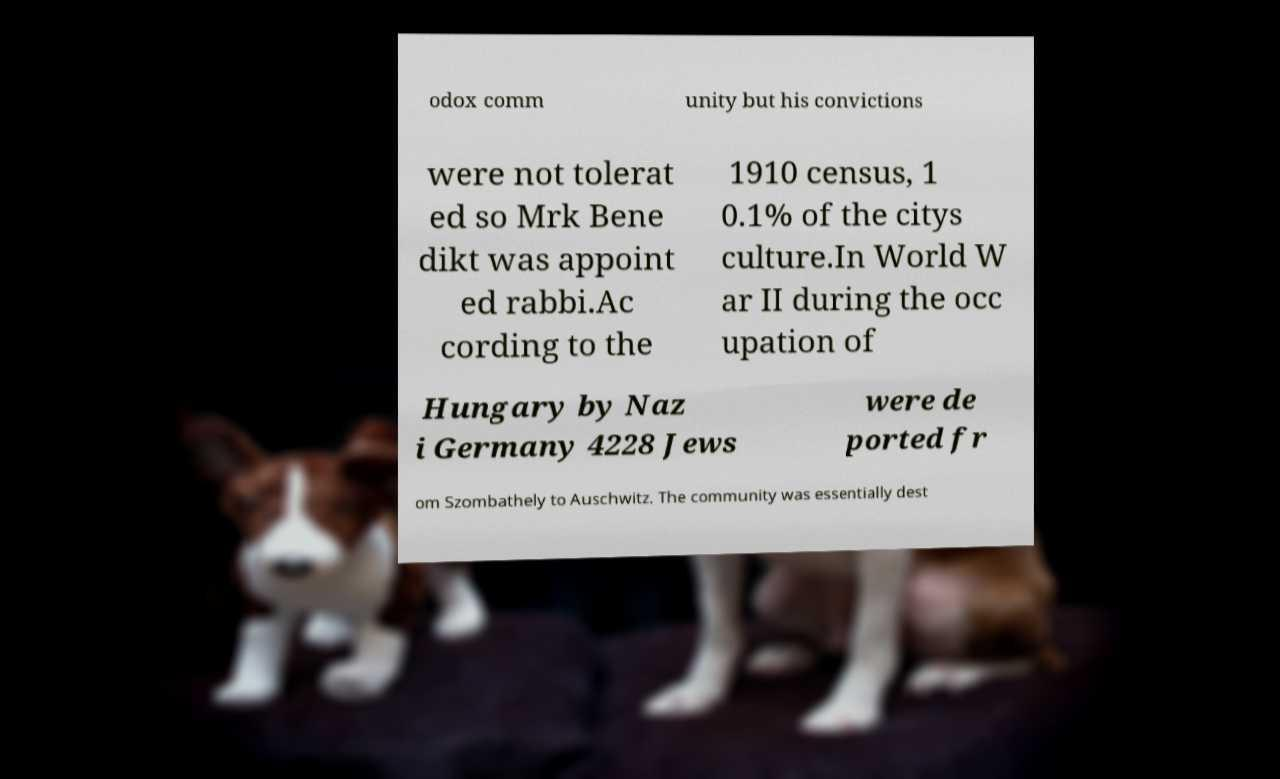For documentation purposes, I need the text within this image transcribed. Could you provide that? odox comm unity but his convictions were not tolerat ed so Mrk Bene dikt was appoint ed rabbi.Ac cording to the 1910 census, 1 0.1% of the citys culture.In World W ar II during the occ upation of Hungary by Naz i Germany 4228 Jews were de ported fr om Szombathely to Auschwitz. The community was essentially dest 